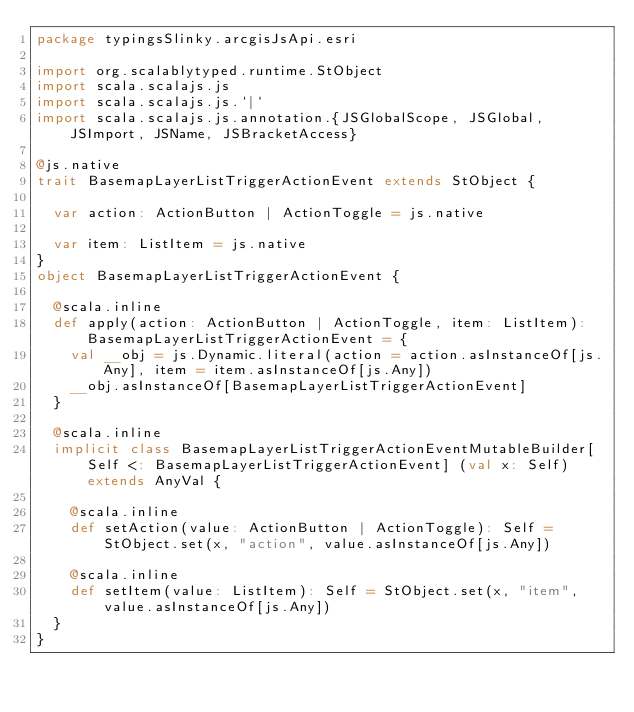<code> <loc_0><loc_0><loc_500><loc_500><_Scala_>package typingsSlinky.arcgisJsApi.esri

import org.scalablytyped.runtime.StObject
import scala.scalajs.js
import scala.scalajs.js.`|`
import scala.scalajs.js.annotation.{JSGlobalScope, JSGlobal, JSImport, JSName, JSBracketAccess}

@js.native
trait BasemapLayerListTriggerActionEvent extends StObject {
  
  var action: ActionButton | ActionToggle = js.native
  
  var item: ListItem = js.native
}
object BasemapLayerListTriggerActionEvent {
  
  @scala.inline
  def apply(action: ActionButton | ActionToggle, item: ListItem): BasemapLayerListTriggerActionEvent = {
    val __obj = js.Dynamic.literal(action = action.asInstanceOf[js.Any], item = item.asInstanceOf[js.Any])
    __obj.asInstanceOf[BasemapLayerListTriggerActionEvent]
  }
  
  @scala.inline
  implicit class BasemapLayerListTriggerActionEventMutableBuilder[Self <: BasemapLayerListTriggerActionEvent] (val x: Self) extends AnyVal {
    
    @scala.inline
    def setAction(value: ActionButton | ActionToggle): Self = StObject.set(x, "action", value.asInstanceOf[js.Any])
    
    @scala.inline
    def setItem(value: ListItem): Self = StObject.set(x, "item", value.asInstanceOf[js.Any])
  }
}
</code> 